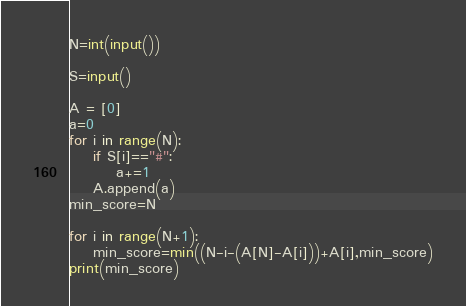Convert code to text. <code><loc_0><loc_0><loc_500><loc_500><_Python_>N=int(input())

S=input()

A = [0]
a=0
for i in range(N):
    if S[i]=="#":
        a+=1
    A.append(a)
min_score=N

for i in range(N+1):
    min_score=min((N-i-(A[N]-A[i]))+A[i],min_score)
print(min_score)</code> 